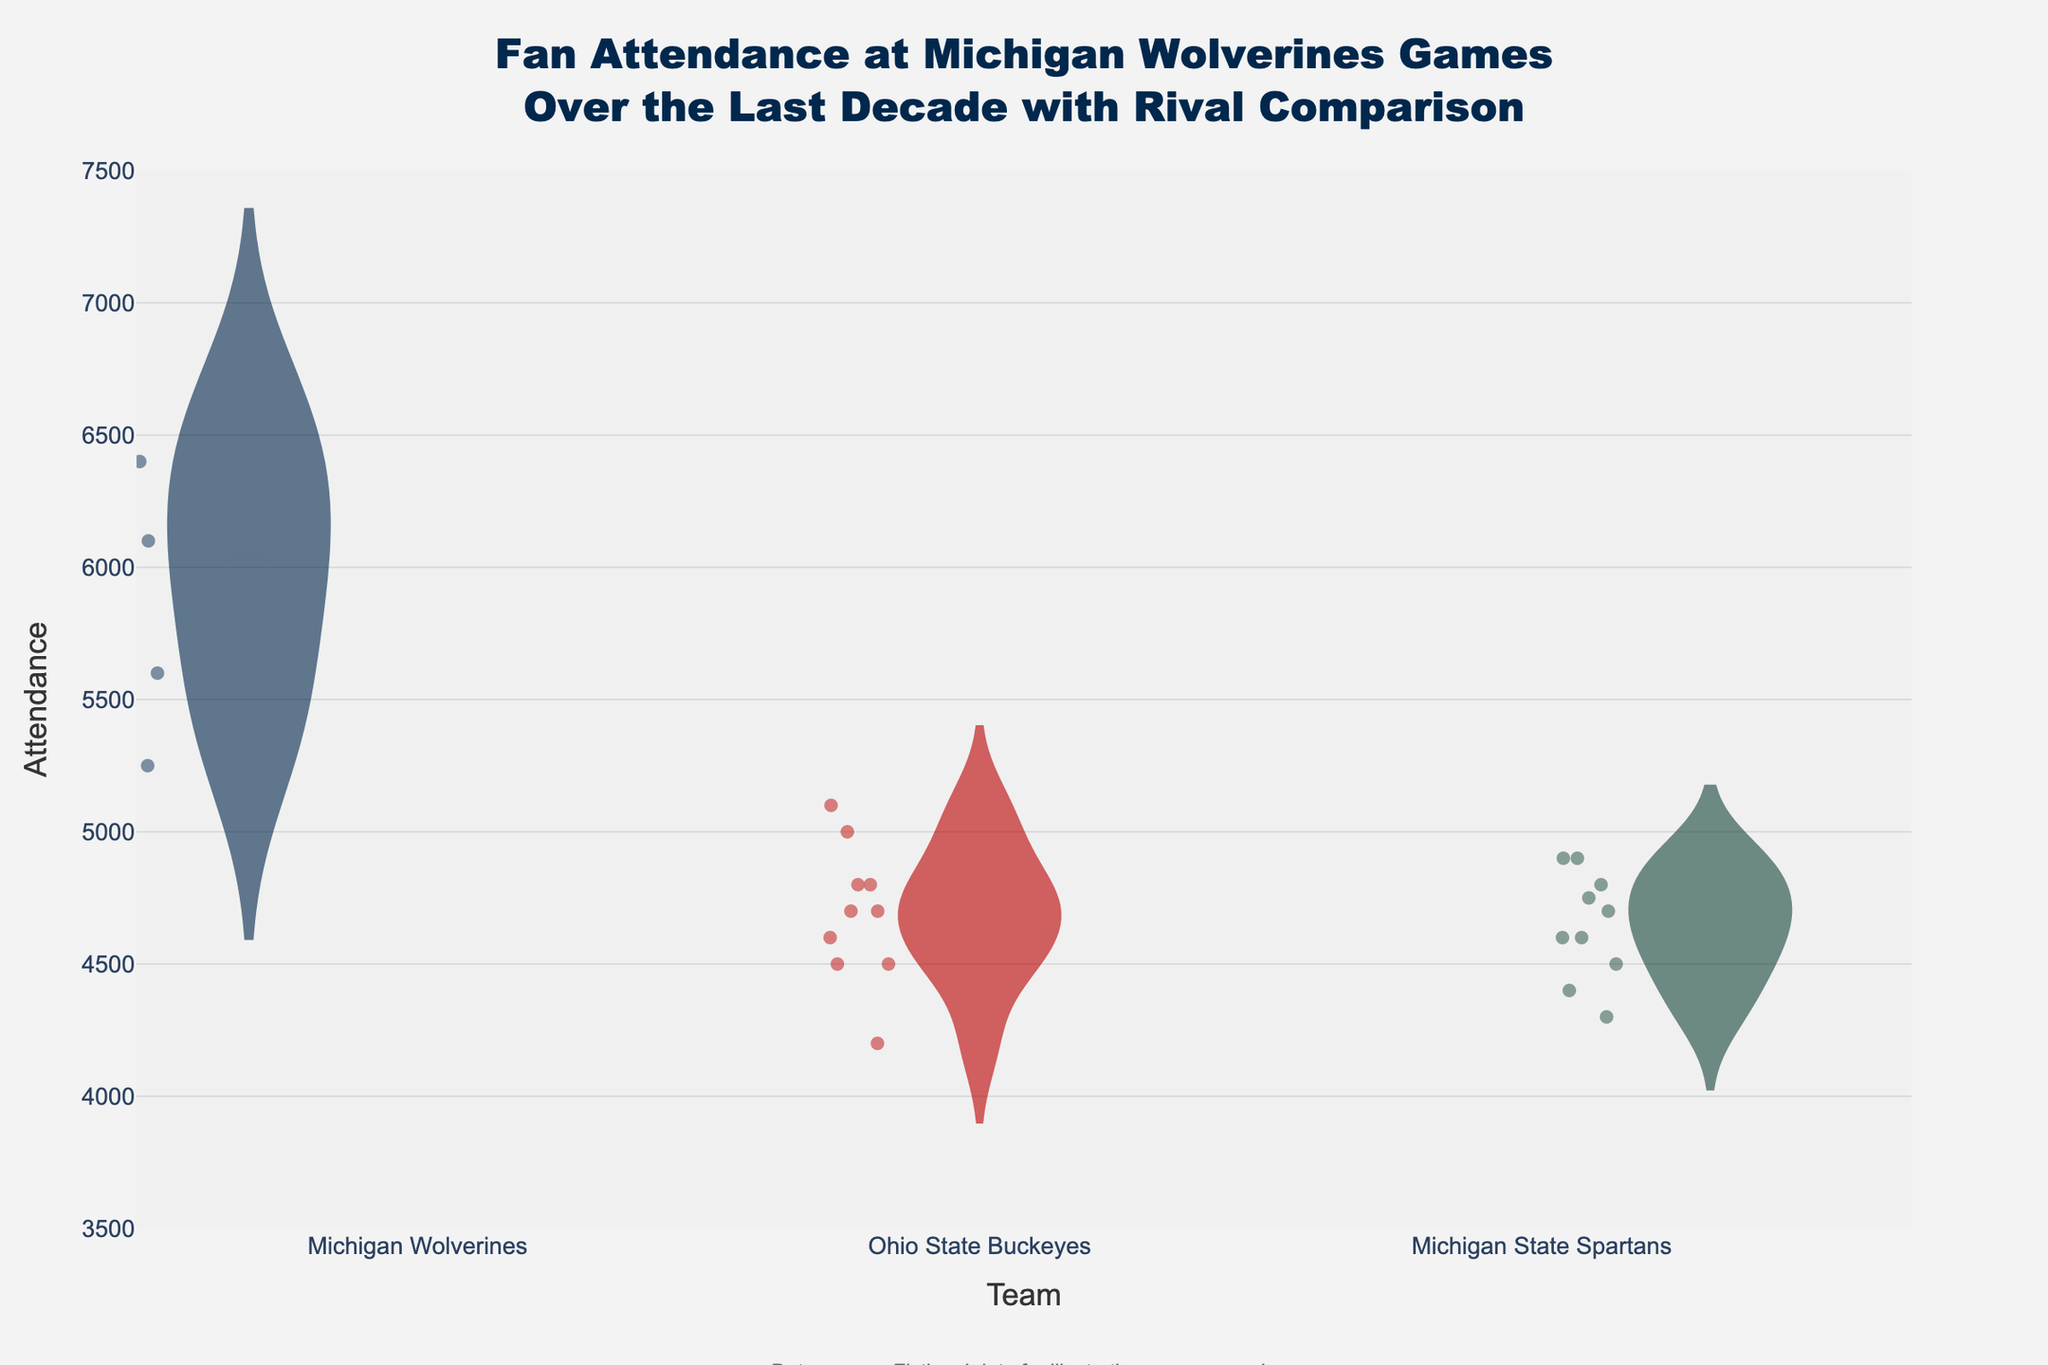What's the title of the chart? The title of the chart is located at the top of the figure and provides a brief description of what the chart represents: "Fan Attendance at Michigan Wolverines Games Over the Last Decade with Rival Comparison".
Answer: Fan Attendance at Michigan Wolverines Games Over the Last Decade with Rival Comparison For which team did the attendance data show the widest range? In a violin plot, the width of the violin indicates the range of attendance values. By observing the violins, one can see that the Michigan Wolverines' data shows a wider spread compared to Ohio State Buckeyes and Michigan State Spartans.
Answer: Michigan Wolverines Between Ohio State Buckeyes and Michigan State Spartans, which team had a higher median attendance? The median attendance is indicated by the white line within the box of the violin plot. Comparing the white lines for Ohio State Buckeyes and Michigan State Spartans, Ohio State Buckeyes have a slightly higher median attendance.
Answer: Ohio State Buckeyes Which team has a higher variability in attendance? Variability in attendance can be assessed by observing the spread and density of the jittered points in the violin plots. Michigan Wolverines show a higher variability in attendance due to the more dispersed points across the y-axis.
Answer: Michigan Wolverines What was the attendance for Michigan Wolverines in 2022? The jittered points within the violin plot show individual attendance values. By tracing the point for the year 2022 within Michigan Wolverines, we see it is at 6700.
Answer: 6700 How does the average attendance for Michigan Wolverines compare to Ohio State Buckeyes? The average attendance is shown by the dashed line within each violin plot. Comparing the dashed lines, Michigan Wolverines exhibit a higher average attendance compared to Ohio State Buckeyes.
Answer: Michigan Wolverines have higher In what year did Michigan State Spartans have their lowest attendance? By identifying the lowest point within the Michigan State Spartans' violin plot, we can trace it to the year 2016.
Answer: 2016 What is the general trend in attendance for Michigan Wolverines over the decade? The violin plot shows consistently increasing points for Michigan Wolverines, indicating a general upward trend in attendance over the decade.
Answer: Increasing Compare the attendance range of Michigan Wolverines and Ohio State Buckeyes. The range can be observed by looking at the extremes of each violin plot. Michigan Wolverines show a broader range from around 5200 to 6700, while Ohio State Buckeyes range between roughly 4200 and 5100.
Answer: Michigan Wolverines have a broader range Are there any outliers visible in the attendance data for Michigan State Spartans? Outliers in a violin plot can be identified as points that fall noticeably outside the main body of the distribution. For Michigan State Spartans, there are no points that appear as distinct outliers.
Answer: No 